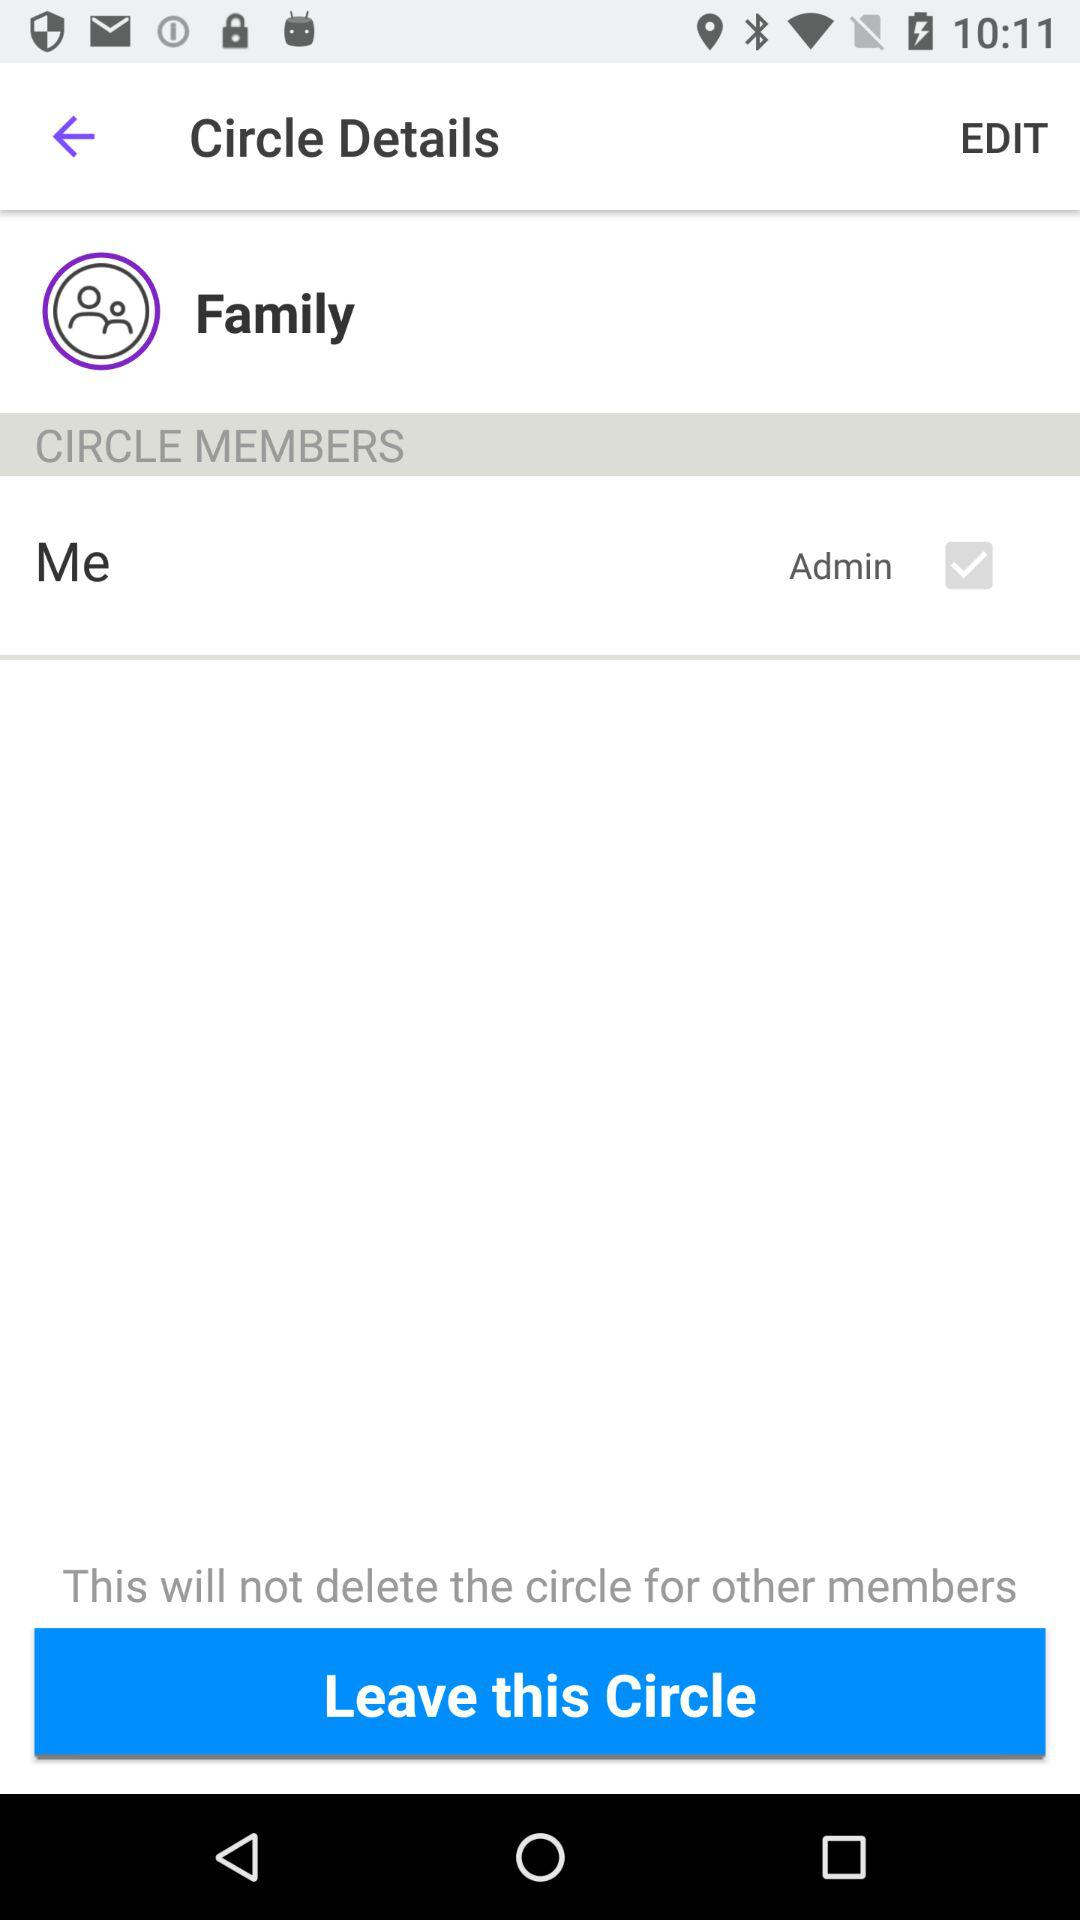What is the status of "Admin"? The status is "on". 